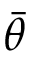<formula> <loc_0><loc_0><loc_500><loc_500>\bar { \theta }</formula> 